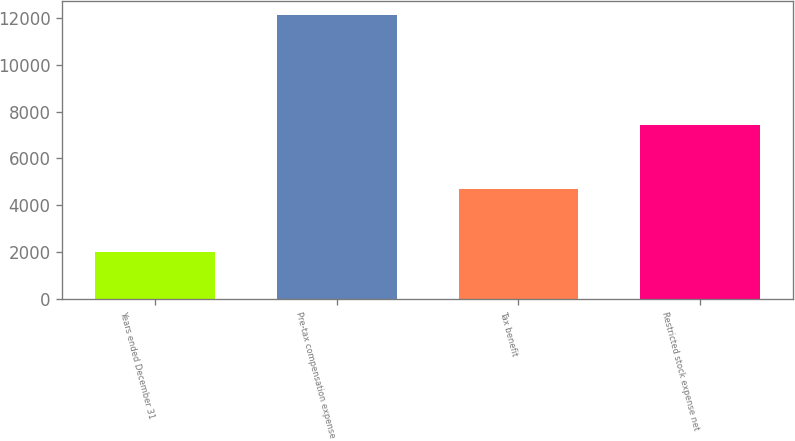Convert chart. <chart><loc_0><loc_0><loc_500><loc_500><bar_chart><fcel>Years ended December 31<fcel>Pre-tax compensation expense<fcel>Tax benefit<fcel>Restricted stock expense net<nl><fcel>2015<fcel>12110<fcel>4687<fcel>7423<nl></chart> 